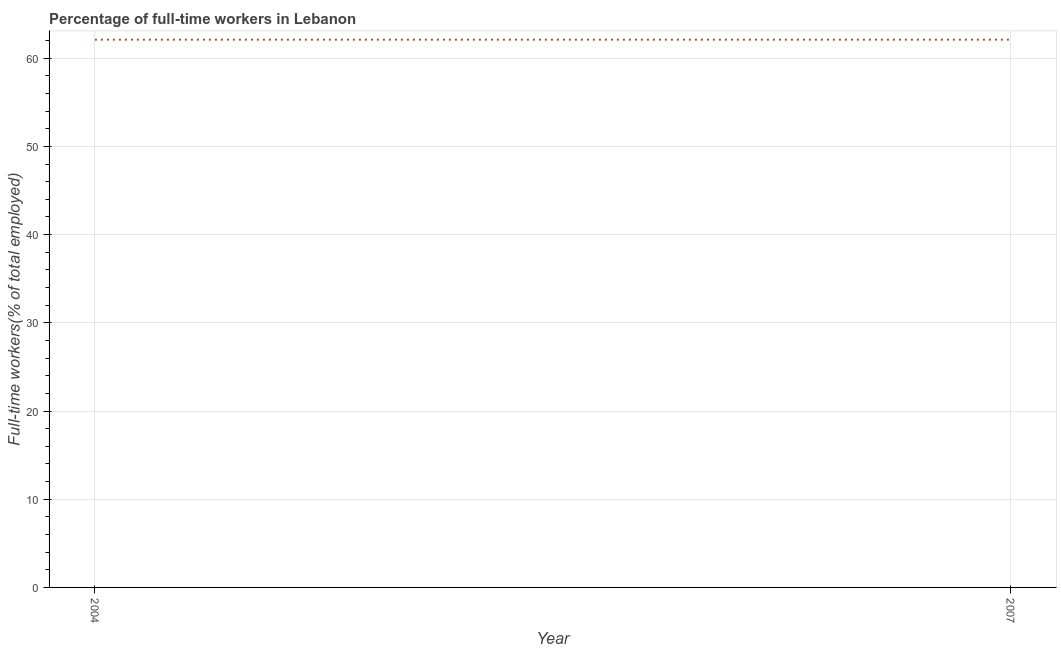What is the percentage of full-time workers in 2004?
Keep it short and to the point. 62.1. Across all years, what is the maximum percentage of full-time workers?
Provide a short and direct response. 62.1. Across all years, what is the minimum percentage of full-time workers?
Keep it short and to the point. 62.1. In which year was the percentage of full-time workers maximum?
Make the answer very short. 2004. In which year was the percentage of full-time workers minimum?
Make the answer very short. 2004. What is the sum of the percentage of full-time workers?
Your answer should be very brief. 124.2. What is the average percentage of full-time workers per year?
Provide a succinct answer. 62.1. What is the median percentage of full-time workers?
Offer a very short reply. 62.1. What is the ratio of the percentage of full-time workers in 2004 to that in 2007?
Your answer should be compact. 1. Does the percentage of full-time workers monotonically increase over the years?
Offer a very short reply. No. How many lines are there?
Give a very brief answer. 1. How many years are there in the graph?
Provide a succinct answer. 2. What is the difference between two consecutive major ticks on the Y-axis?
Your response must be concise. 10. Are the values on the major ticks of Y-axis written in scientific E-notation?
Give a very brief answer. No. Does the graph contain any zero values?
Give a very brief answer. No. Does the graph contain grids?
Give a very brief answer. Yes. What is the title of the graph?
Ensure brevity in your answer.  Percentage of full-time workers in Lebanon. What is the label or title of the Y-axis?
Provide a succinct answer. Full-time workers(% of total employed). What is the Full-time workers(% of total employed) of 2004?
Your response must be concise. 62.1. What is the Full-time workers(% of total employed) of 2007?
Offer a very short reply. 62.1. What is the ratio of the Full-time workers(% of total employed) in 2004 to that in 2007?
Your answer should be compact. 1. 